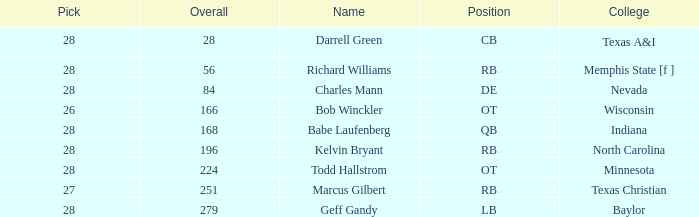What is the total of the selections from texas a&i college in rounds exceeding the first one? None. 